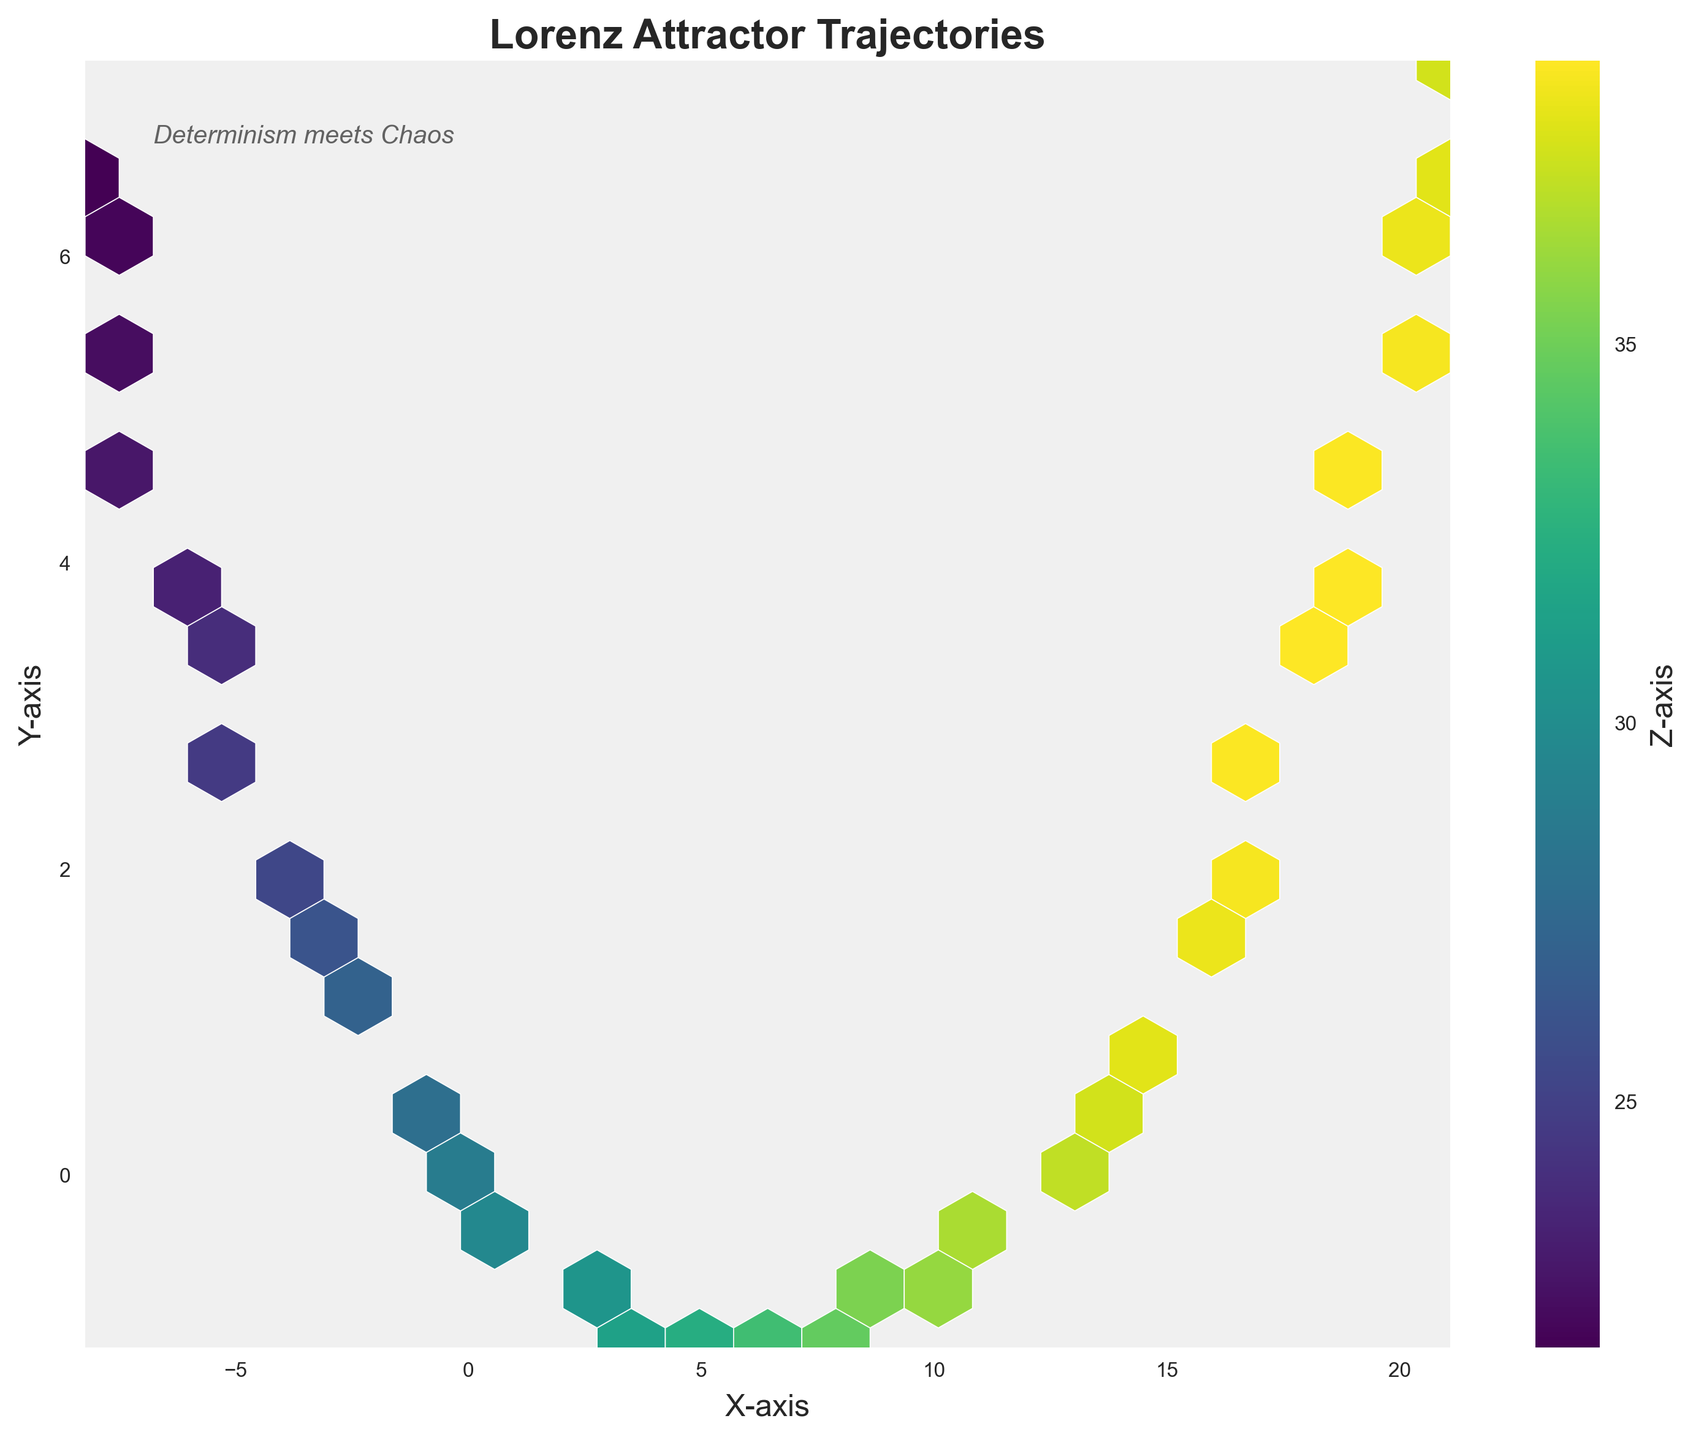What is the title of the chart? The title of the chart is usually displayed at the top of the figure. In this case, it reads "Lorenz Attractor Trajectories."
Answer: Lorenz Attractor Trajectories What does the color bar label indicate? The color bar is typically used to represent the value range of a particular variable. Here the label on the color bar indicates it represents the "Z-axis."
Answer: Z-axis What are the axes labels? Axes labels are typically located beside the respective axes. The X-axis is labeled as "X-axis," and the Y-axis is labeled as "Y-axis."
Answer: X-axis, Y-axis What colors dominate the hexbin plot? The hexbin plot utilizes a color map to show density, and dominant colors can be observed visually. This plot uses a 'viridis' colormap, which typically includes shades of yellow, green, and blue.
Answer: Yellow, Green, Blue What does a hexbin plot help visualize in this context? A hexbin plot helps show the density of data points. In this context, it shows the density of Lorenz attractor trajectories in the X-Y plane, with colors representing the Z-values.
Answer: Density of Lorenz attractor trajectories Are there more high Z-values or low Z-values represented in the density plot? By looking at the color distribution, we can determine whether higher or lower Z-values dominate. The plot shows more dark regions, indicating higher Z-values dominate.
Answer: Higher Z-values What is the density pattern along the X-axis? To understand the density pattern along the X-axis, examine the concentration of hexagons along this axis. It reveals a denser region around the middle (near the origin) and less dense towards the edges.
Answer: Higher density around the middle Compare the density of trajectories in the negative X-region to the positive X-region. By visually comparing the density of hexagons in the negative and positive X-regions, we find that the negative X-region has a lesser density of trajectories compared to the positive X-region.
Answer: Positive X-region has higher density Considering the text note "Determinism meets Chaos," how does the plot exemplify this concept? The Lorenz attractor is an example of how deterministic systems can exhibit chaotic behavior. This plot, showing varying trajectories based on close initial conditions, captures the essence of sensitive dependence on initial conditions, embodying the intersection of determinism and chaos theory.
Answer: Sensitive dependence on initial conditions If we group the X-values below zero and Y-values above zero, where is the highest density? To answer this, observe the hexbin density in the quadrants defined by X < 0 and Y > 0. The hexbin plot shows a less dense region in this quadrant compared to others.
Answer: Lower density 